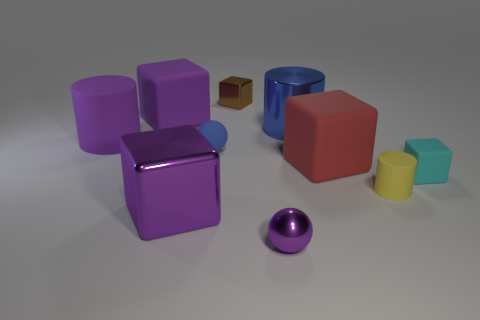Subtract all purple rubber blocks. How many blocks are left? 4 Subtract all cyan blocks. How many blocks are left? 4 Subtract 1 blocks. How many blocks are left? 4 Subtract all gray cubes. Subtract all gray cylinders. How many cubes are left? 5 Subtract all spheres. How many objects are left? 8 Subtract 0 yellow balls. How many objects are left? 10 Subtract all tiny purple metal cylinders. Subtract all small blue matte spheres. How many objects are left? 9 Add 9 blue spheres. How many blue spheres are left? 10 Add 8 blue matte things. How many blue matte things exist? 9 